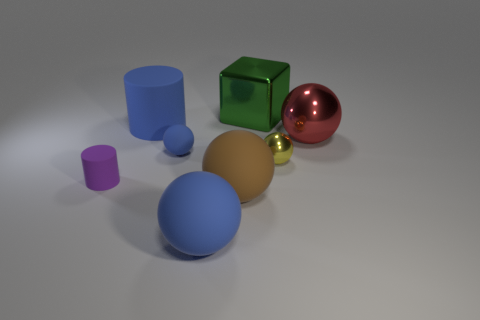Subtract all gray cylinders. How many blue spheres are left? 2 Subtract 1 balls. How many balls are left? 4 Subtract all blue balls. How many balls are left? 3 Subtract all large matte spheres. How many spheres are left? 3 Add 1 purple rubber cylinders. How many objects exist? 9 Subtract all red balls. Subtract all brown blocks. How many balls are left? 4 Subtract all cylinders. How many objects are left? 6 Add 1 tiny matte spheres. How many tiny matte spheres are left? 2 Add 1 yellow spheres. How many yellow spheres exist? 2 Subtract 0 yellow cylinders. How many objects are left? 8 